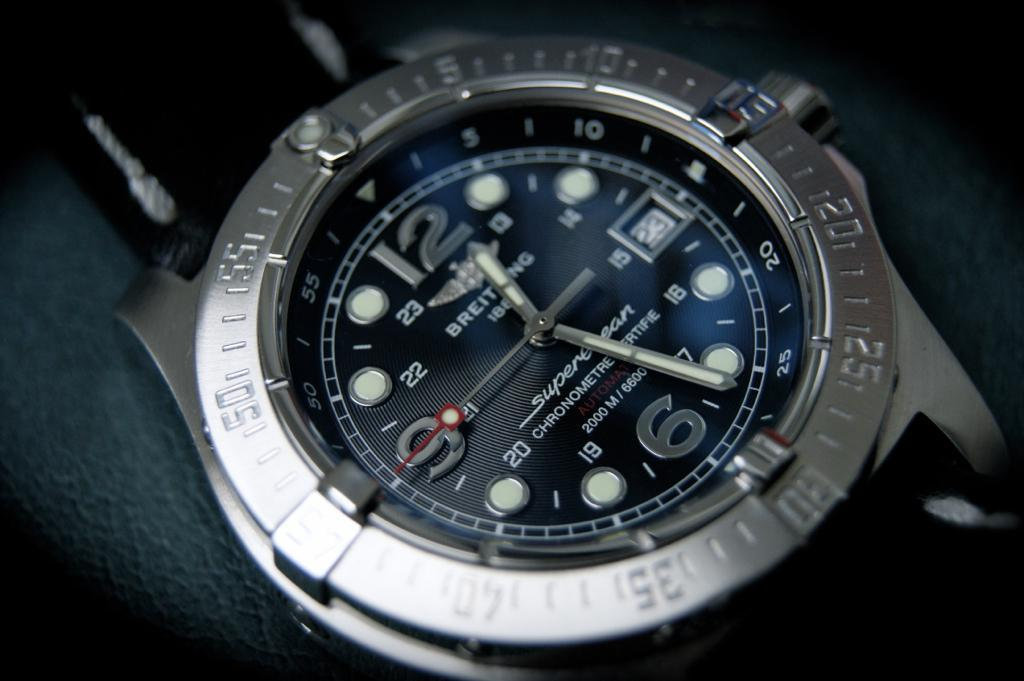<image>
Share a concise interpretation of the image provided. The grey and black watch displays a time of 12:26. 